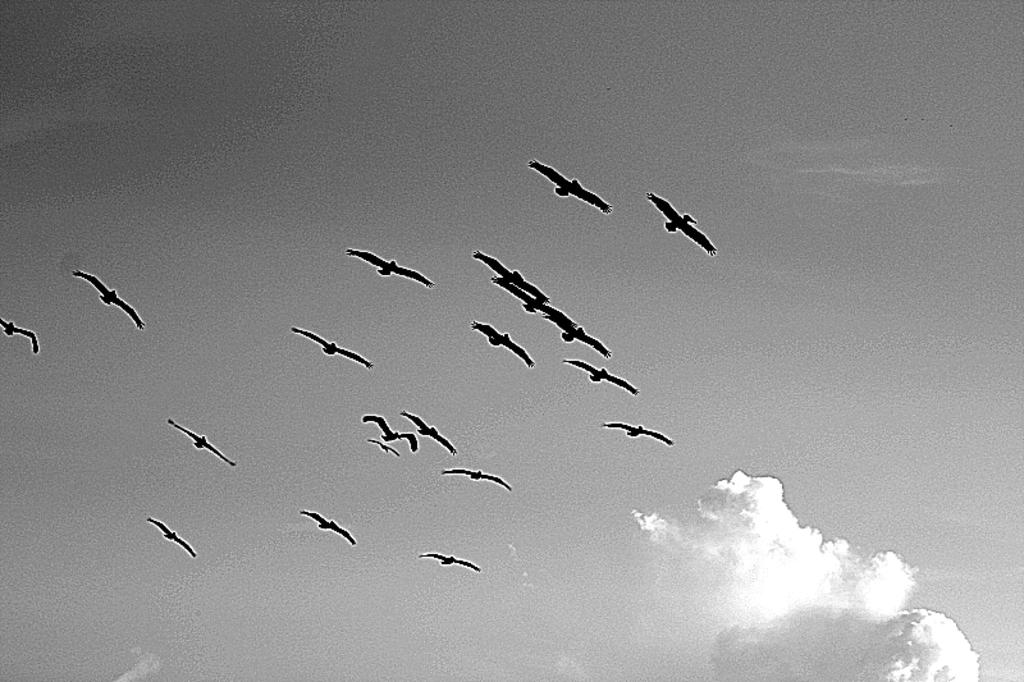What is happening in the sky in the image? There are birds flying in the sky. What else can be seen in the sky besides the birds? Clouds are visible in the sky. Where is the queen sitting with her cub in the image? There is no queen or cub present in the image; it only features birds flying in the sky and clouds. 